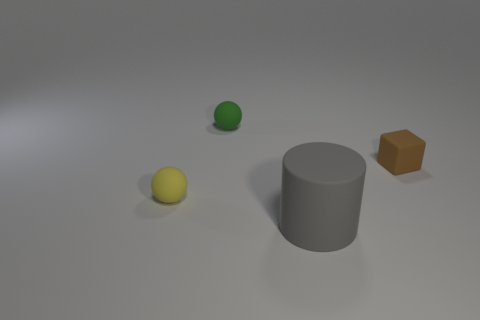Add 1 big gray things. How many objects exist? 5 Subtract all blocks. How many objects are left? 3 Add 1 large gray cylinders. How many large gray cylinders are left? 2 Add 1 tiny yellow rubber balls. How many tiny yellow rubber balls exist? 2 Subtract 0 purple blocks. How many objects are left? 4 Subtract all green spheres. Subtract all small brown rubber cylinders. How many objects are left? 3 